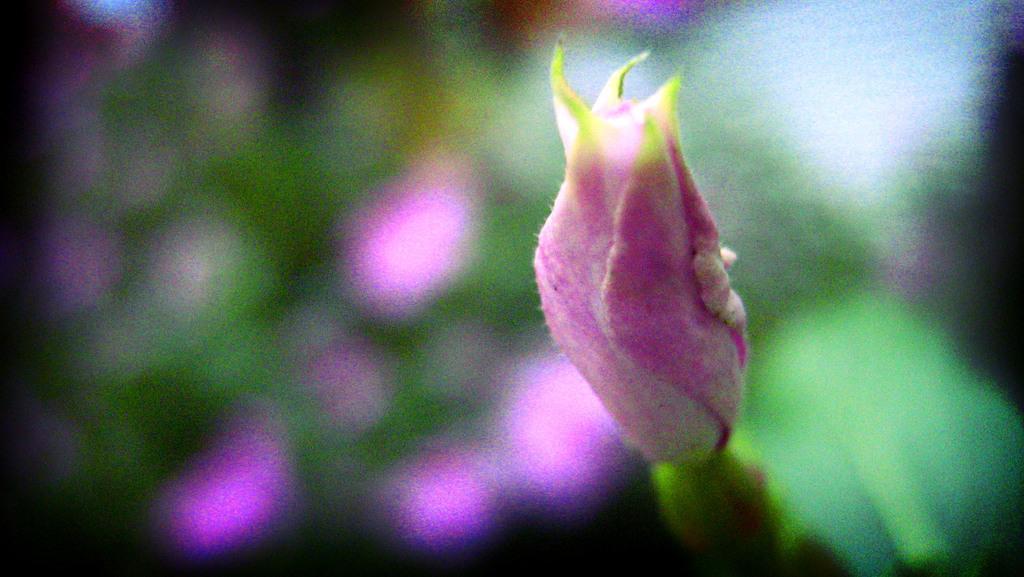Please provide a concise description of this image. In the foreground of the picture there is a flower. The background is blurred. 